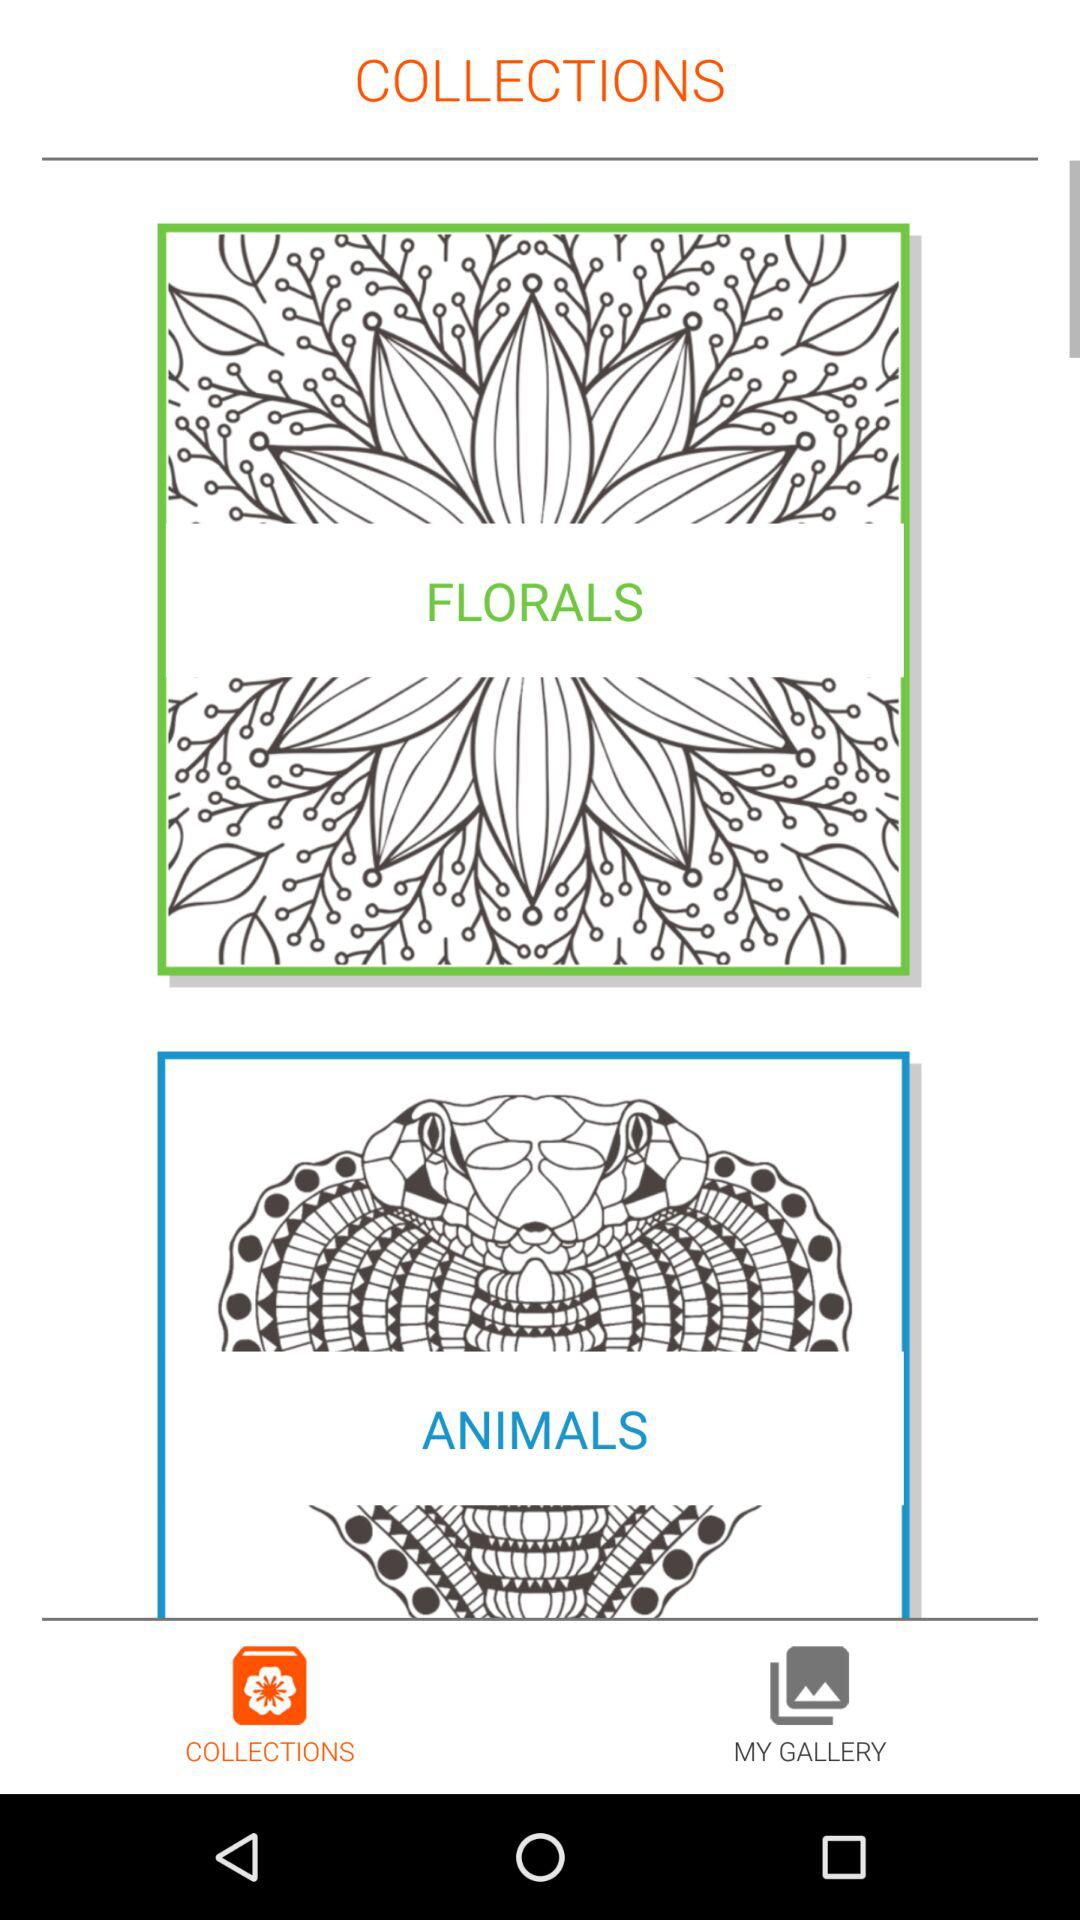Which tab is selected? The selected tab is "COLLECTIONS". 